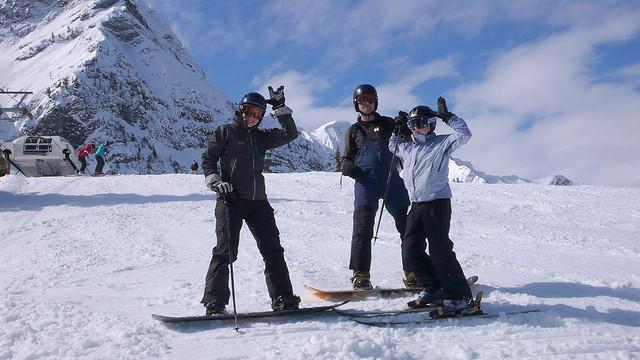How many skis are in this picture?
Give a very brief answer. 2. How many people have snowboards?
Give a very brief answer. 2. How many people are in the photo?
Give a very brief answer. 3. 